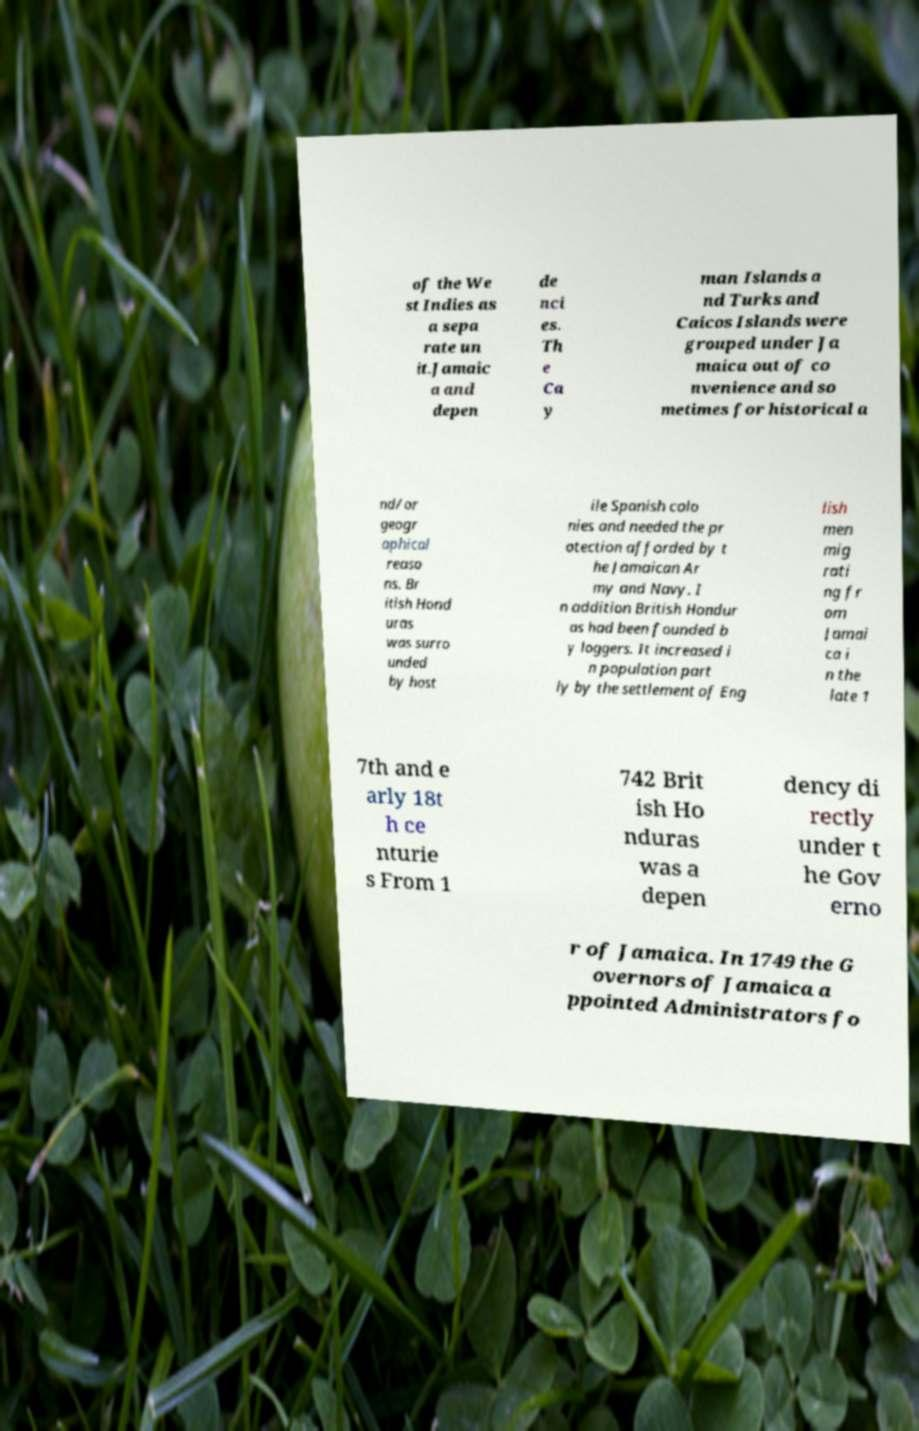Can you read and provide the text displayed in the image?This photo seems to have some interesting text. Can you extract and type it out for me? of the We st Indies as a sepa rate un it.Jamaic a and depen de nci es. Th e Ca y man Islands a nd Turks and Caicos Islands were grouped under Ja maica out of co nvenience and so metimes for historical a nd/or geogr aphical reaso ns. Br itish Hond uras was surro unded by host ile Spanish colo nies and needed the pr otection afforded by t he Jamaican Ar my and Navy. I n addition British Hondur as had been founded b y loggers. It increased i n population part ly by the settlement of Eng lish men mig rati ng fr om Jamai ca i n the late 1 7th and e arly 18t h ce nturie s From 1 742 Brit ish Ho nduras was a depen dency di rectly under t he Gov erno r of Jamaica. In 1749 the G overnors of Jamaica a ppointed Administrators fo 